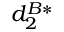Convert formula to latex. <formula><loc_0><loc_0><loc_500><loc_500>d _ { 2 } ^ { B * }</formula> 